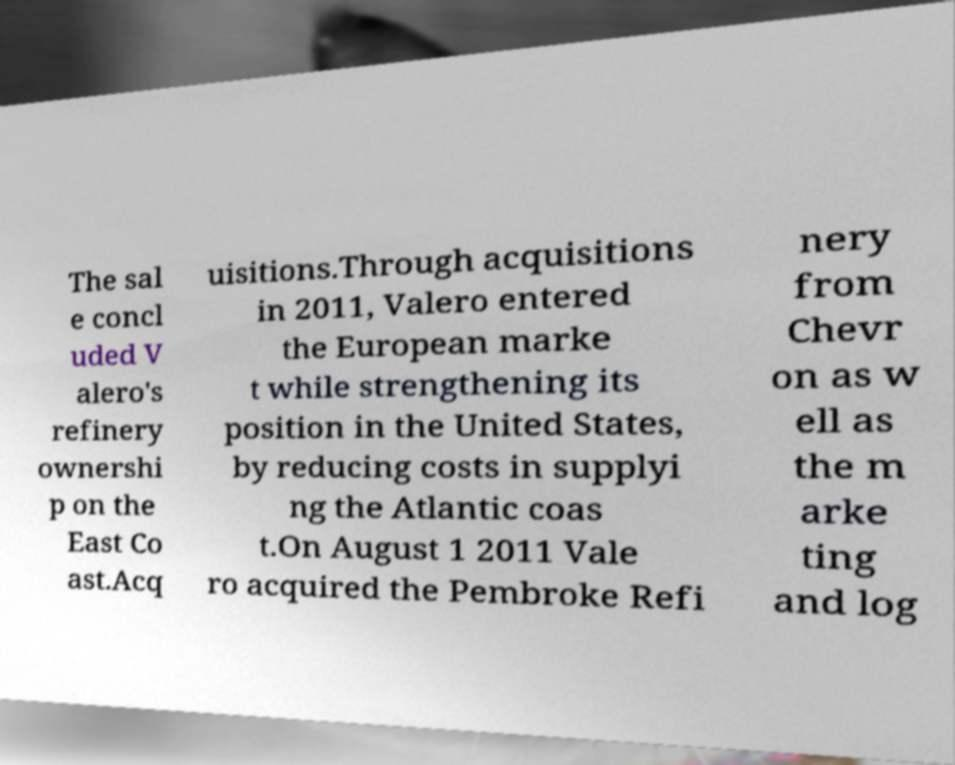Could you assist in decoding the text presented in this image and type it out clearly? The sal e concl uded V alero's refinery ownershi p on the East Co ast.Acq uisitions.Through acquisitions in 2011, Valero entered the European marke t while strengthening its position in the United States, by reducing costs in supplyi ng the Atlantic coas t.On August 1 2011 Vale ro acquired the Pembroke Refi nery from Chevr on as w ell as the m arke ting and log 